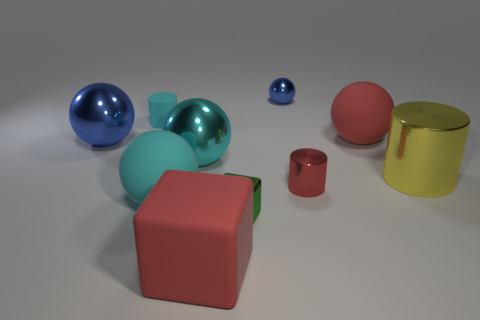Subtract all red spheres. How many spheres are left? 4 Subtract all red rubber spheres. How many spheres are left? 4 Subtract all yellow spheres. Subtract all green cylinders. How many spheres are left? 5 Subtract all cubes. How many objects are left? 8 Add 1 cyan things. How many cyan things exist? 4 Subtract 1 red balls. How many objects are left? 9 Subtract all red metal blocks. Subtract all red metal cylinders. How many objects are left? 9 Add 2 big blue spheres. How many big blue spheres are left? 3 